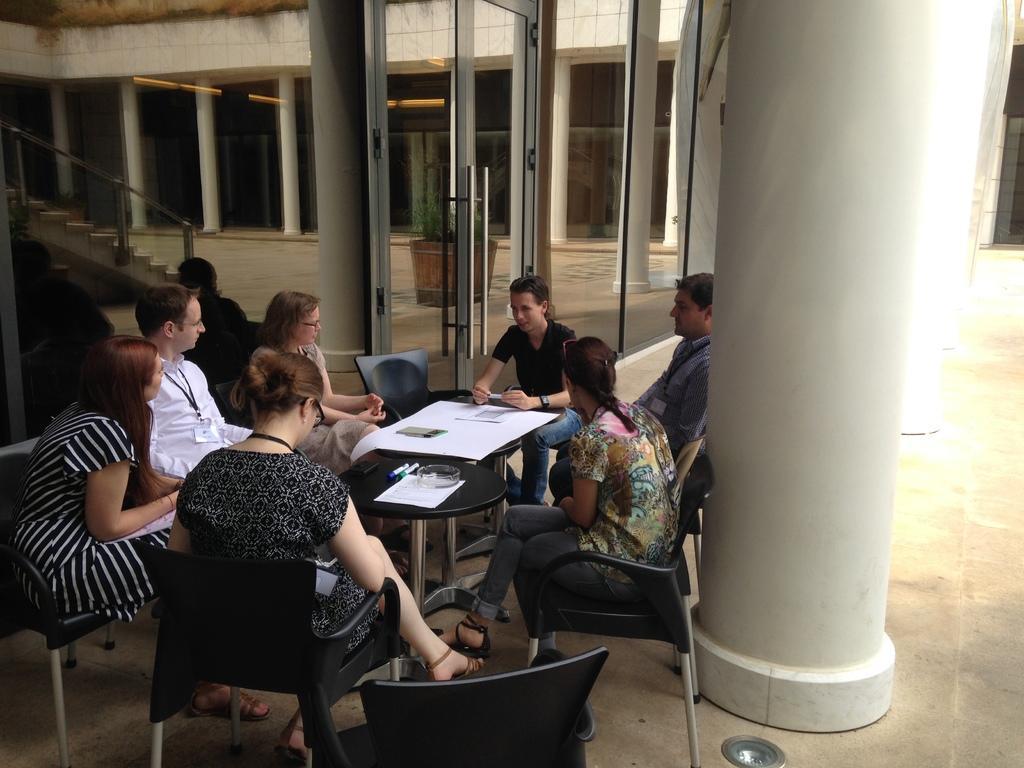Please provide a concise description of this image. This image is clicked outside the building. There are seven people sitting in the chairs around the table. To the left, the woman is wearing white and black dress. To the right, the man is wearing blue shirt. In the background, there is a mirror, door, pillars. To the right, there is a floor in the bottom. 